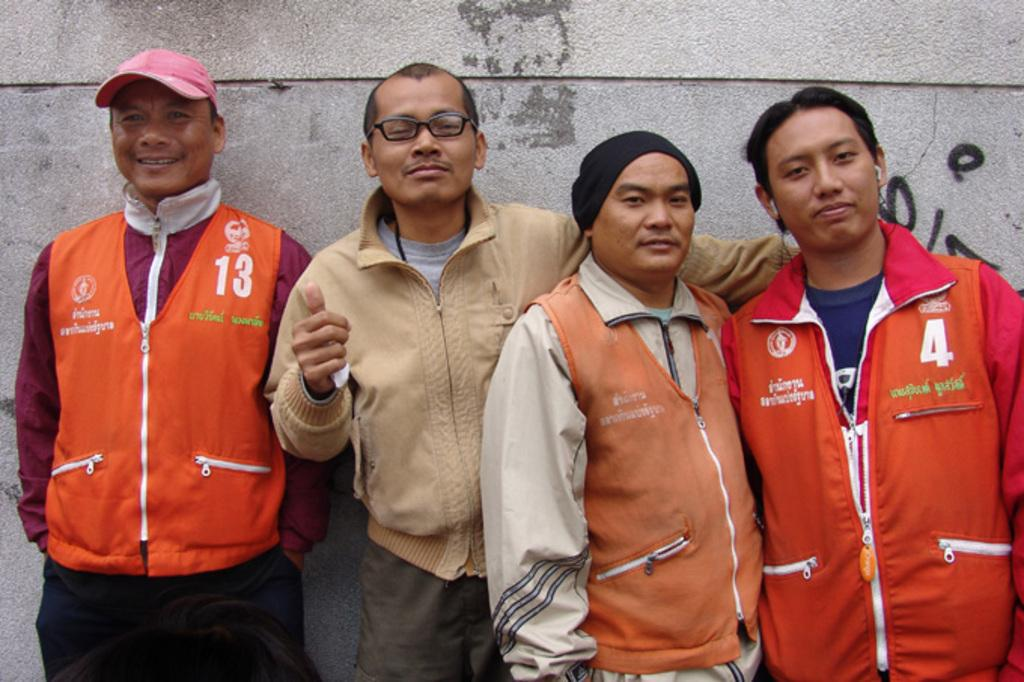<image>
Share a concise interpretation of the image provided. Two men in orange vests with the numbers 13 and 4 on them 